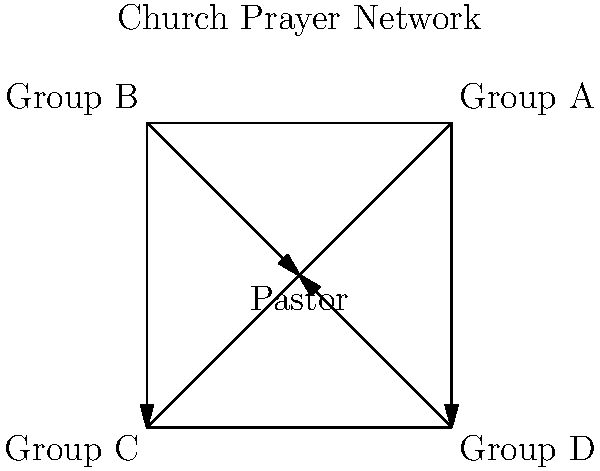In the church prayer network shown above, which prayer group acts as a "bridge" between two other groups that are not directly connected to each other? To determine which prayer group acts as a "bridge" between two other groups that are not directly connected, we need to analyze the network structure:

1. The Pastor is connected to all four prayer groups (A, B, C, and D).
2. Group A is directly connected to the Pastor and Group D.
3. Group B is directly connected to the Pastor and Group C.
4. Group C is directly connected to the Pastor and Group B.
5. Group D is directly connected to the Pastor and Group A.

We can see that:
- Groups A and B are not directly connected.
- Groups C and D are not directly connected.

To find the "bridge," we need to identify which group connects these non-directly connected pairs:

- Group C connects the Pastor to Group B.
- Group D connects the Pastor to Group A.

Therefore, the Pastor acts as the bridge between Groups A and B, as well as between Groups C and D.

In a spiritual context, this network structure emphasizes the Pastor's role in facilitating communication and prayer support between different groups within the church community.
Answer: Pastor 